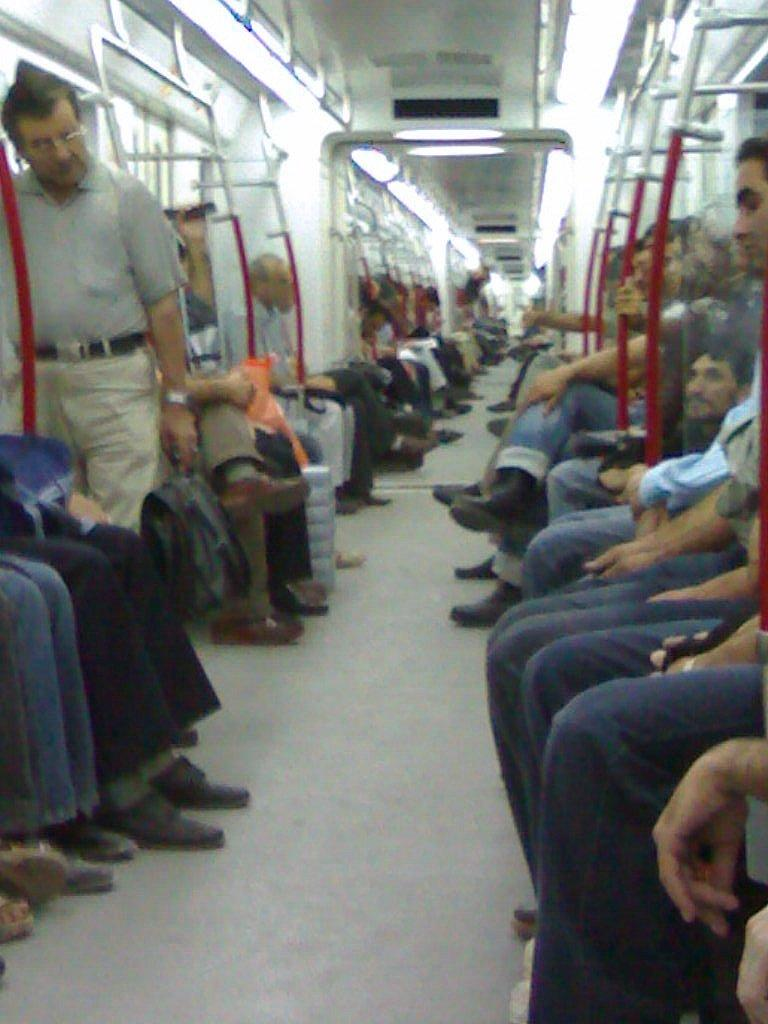What is the setting of the image? The image shows an inner view of a train. Can you describe the man standing in the train? The man is holding a bag in his hand and is wearing spectacles. What are the other passengers in the train doing? There are people seated in the train. How many geese are sitting on the crib in the image? There are no geese or cribs present in the image; it shows an inner view of a train with passengers. 